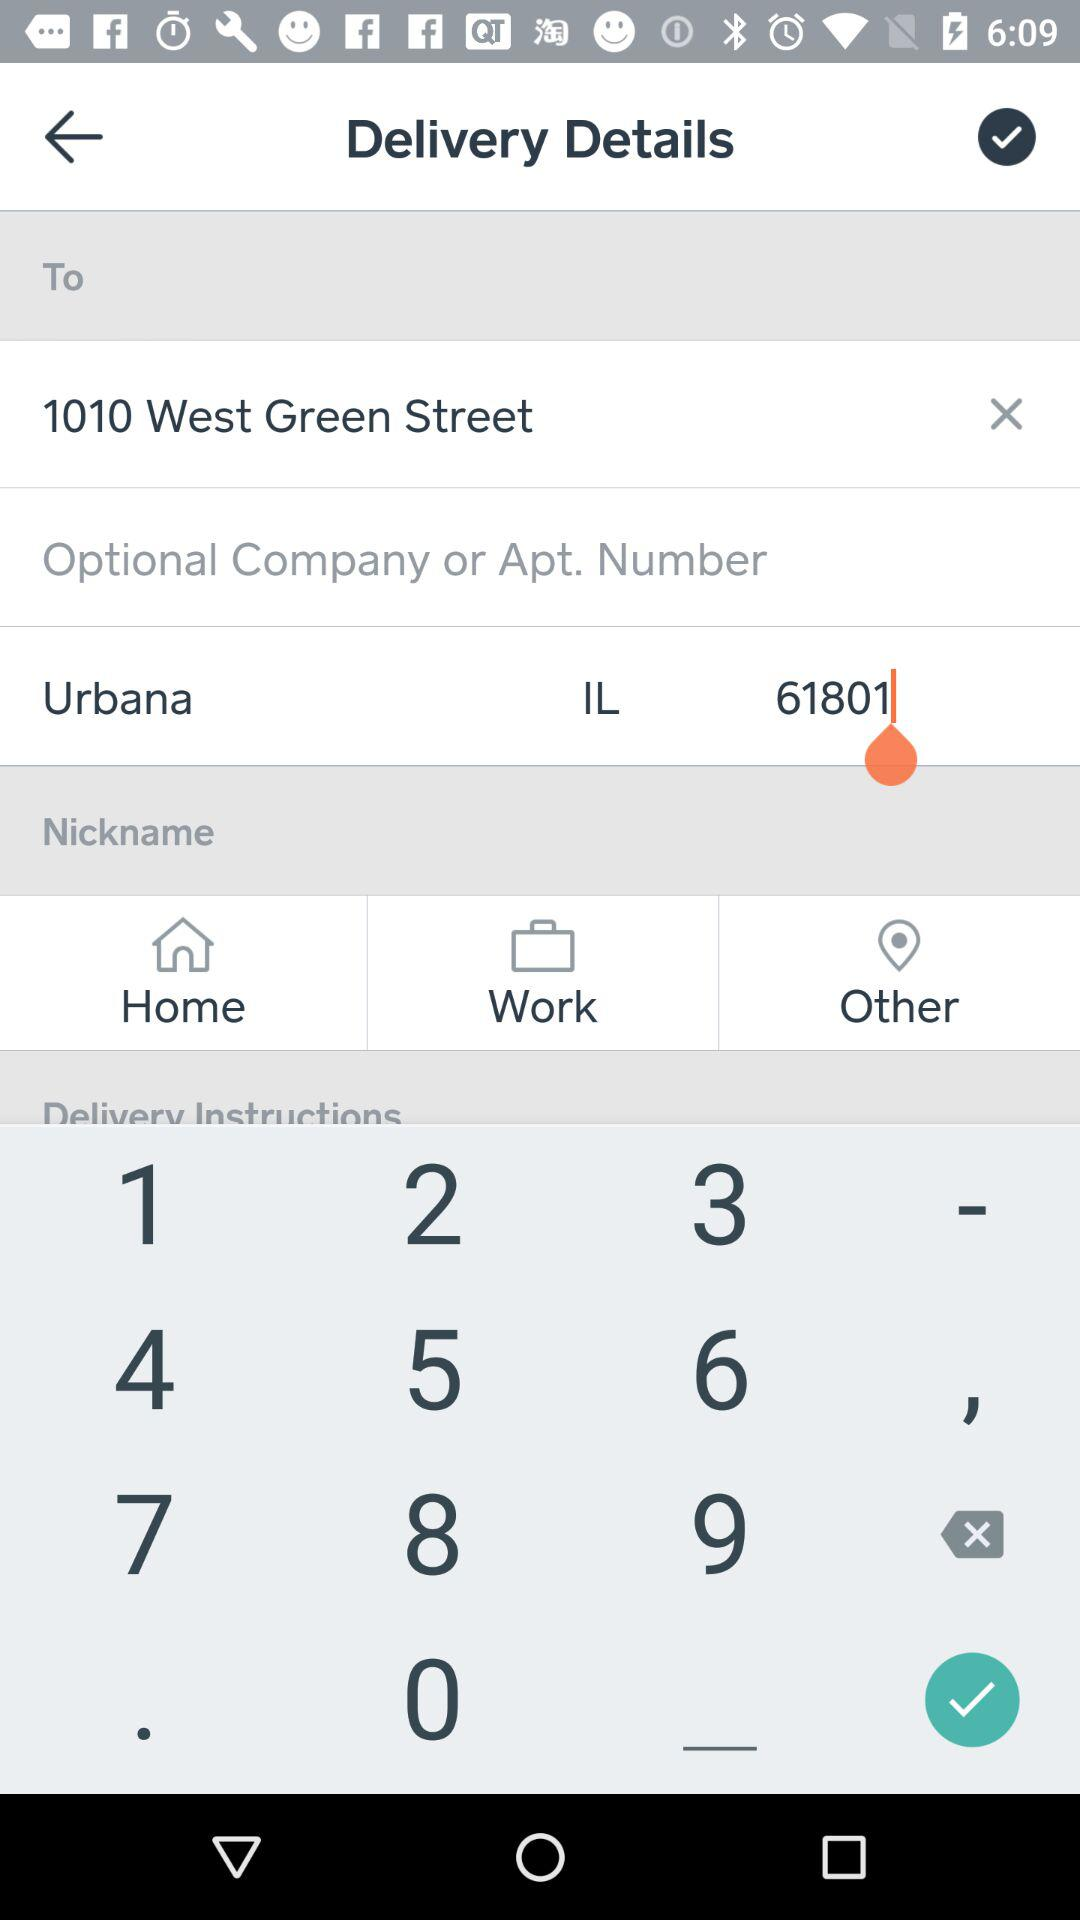What is the location for delivery? The location for delivery is 1010 West Green Street, Urbana, IL, 61801. 